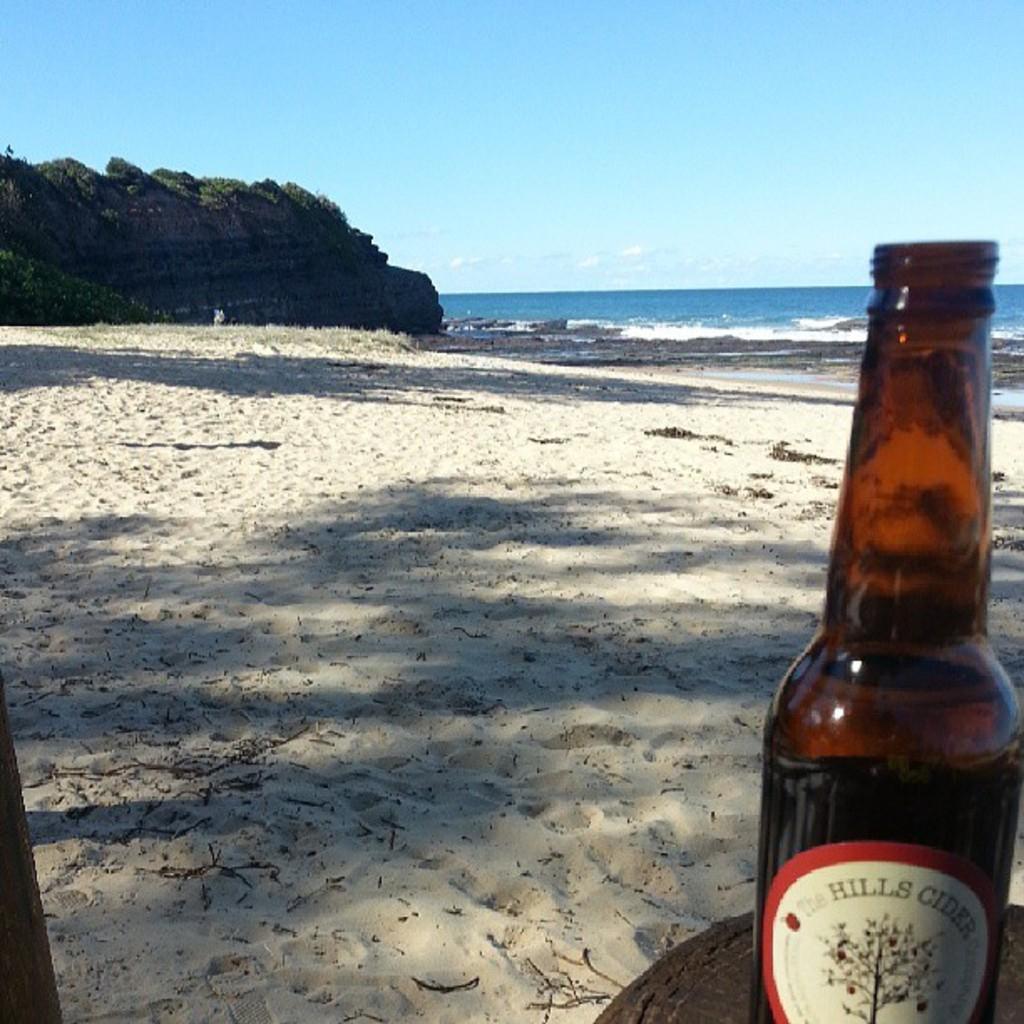What is the name of this cider?
Ensure brevity in your answer.  The hills cider. What is the brand of alcohol?
Make the answer very short. Hills cider. 